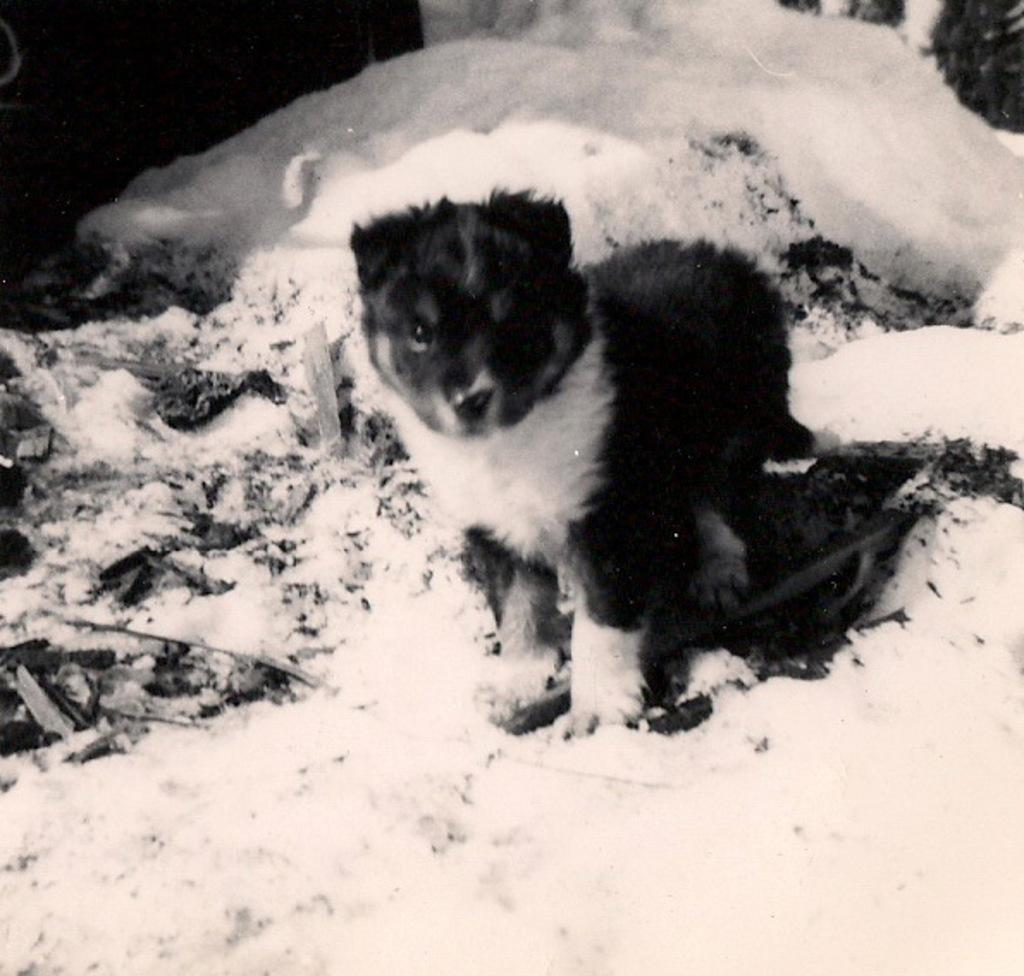What animal can be seen in the image? There is a puppy in the image. What is the puppy standing on? The puppy is standing on the snow. What object is beside the puppy? There is a sleeper beside the puppy. What can be seen in the background or foreground of the image? Sticks are visible in the image. How many brothers does the puppy have in the image? There is no information about the puppy's brothers in the image. What type of sail can be seen in the image? There is no sail present in the image. 